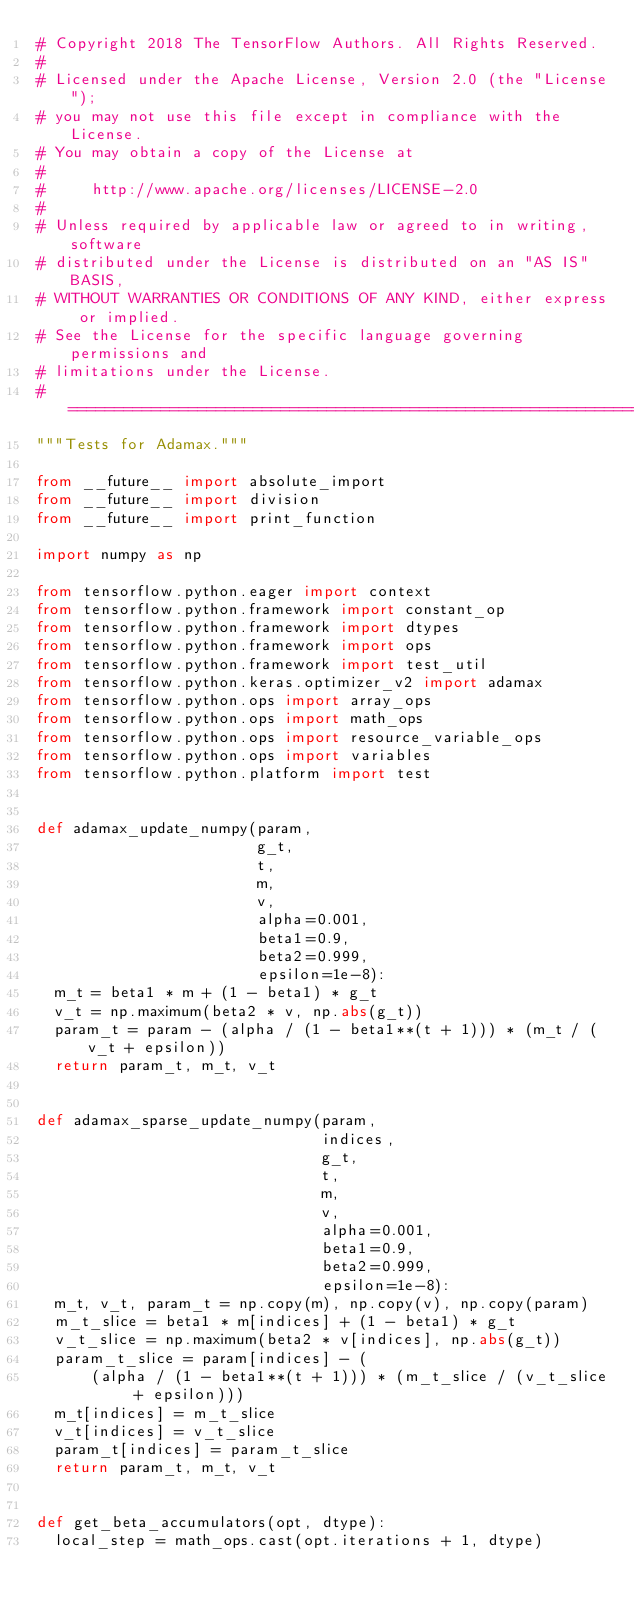<code> <loc_0><loc_0><loc_500><loc_500><_Python_># Copyright 2018 The TensorFlow Authors. All Rights Reserved.
#
# Licensed under the Apache License, Version 2.0 (the "License");
# you may not use this file except in compliance with the License.
# You may obtain a copy of the License at
#
#     http://www.apache.org/licenses/LICENSE-2.0
#
# Unless required by applicable law or agreed to in writing, software
# distributed under the License is distributed on an "AS IS" BASIS,
# WITHOUT WARRANTIES OR CONDITIONS OF ANY KIND, either express or implied.
# See the License for the specific language governing permissions and
# limitations under the License.
# ==============================================================================
"""Tests for Adamax."""

from __future__ import absolute_import
from __future__ import division
from __future__ import print_function

import numpy as np

from tensorflow.python.eager import context
from tensorflow.python.framework import constant_op
from tensorflow.python.framework import dtypes
from tensorflow.python.framework import ops
from tensorflow.python.framework import test_util
from tensorflow.python.keras.optimizer_v2 import adamax
from tensorflow.python.ops import array_ops
from tensorflow.python.ops import math_ops
from tensorflow.python.ops import resource_variable_ops
from tensorflow.python.ops import variables
from tensorflow.python.platform import test


def adamax_update_numpy(param,
                        g_t,
                        t,
                        m,
                        v,
                        alpha=0.001,
                        beta1=0.9,
                        beta2=0.999,
                        epsilon=1e-8):
  m_t = beta1 * m + (1 - beta1) * g_t
  v_t = np.maximum(beta2 * v, np.abs(g_t))
  param_t = param - (alpha / (1 - beta1**(t + 1))) * (m_t / (v_t + epsilon))
  return param_t, m_t, v_t


def adamax_sparse_update_numpy(param,
                               indices,
                               g_t,
                               t,
                               m,
                               v,
                               alpha=0.001,
                               beta1=0.9,
                               beta2=0.999,
                               epsilon=1e-8):
  m_t, v_t, param_t = np.copy(m), np.copy(v), np.copy(param)
  m_t_slice = beta1 * m[indices] + (1 - beta1) * g_t
  v_t_slice = np.maximum(beta2 * v[indices], np.abs(g_t))
  param_t_slice = param[indices] - (
      (alpha / (1 - beta1**(t + 1))) * (m_t_slice / (v_t_slice + epsilon)))
  m_t[indices] = m_t_slice
  v_t[indices] = v_t_slice
  param_t[indices] = param_t_slice
  return param_t, m_t, v_t


def get_beta_accumulators(opt, dtype):
  local_step = math_ops.cast(opt.iterations + 1, dtype)</code> 